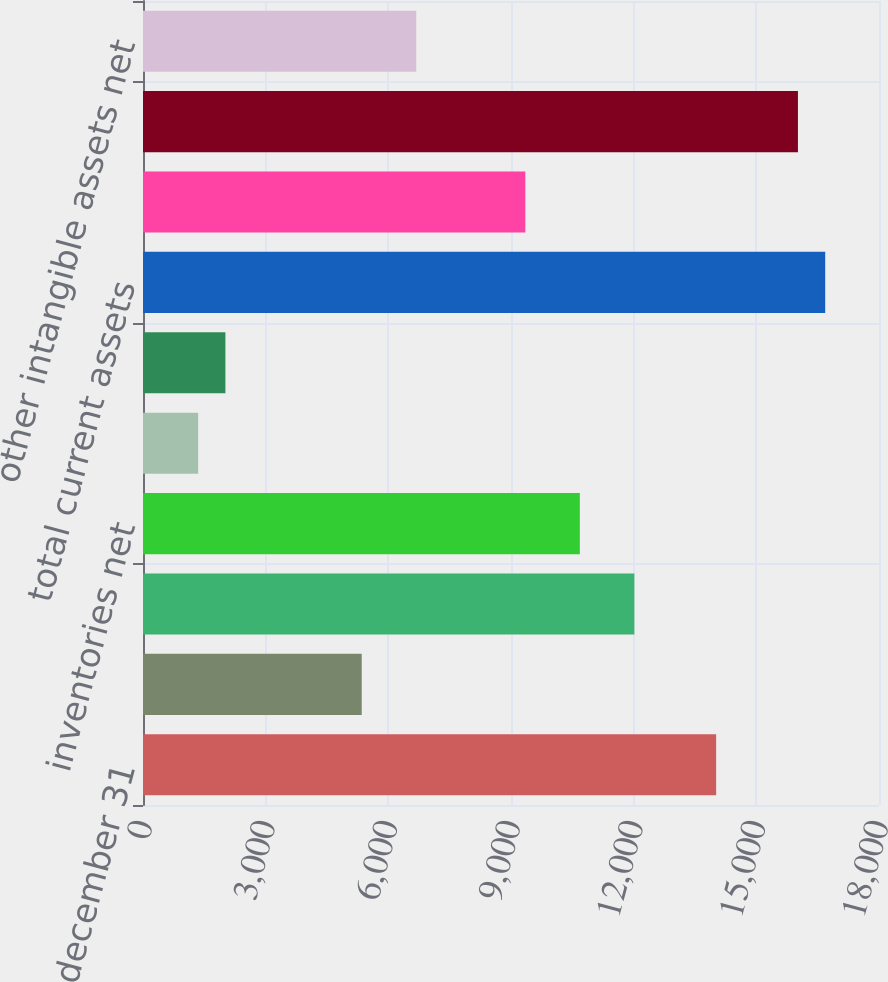Convert chart to OTSL. <chart><loc_0><loc_0><loc_500><loc_500><bar_chart><fcel>december 31<fcel>cash and cash equivalents<fcel>accounts receivable net of<fcel>inventories net<fcel>deferred income taxes<fcel>Prepaid expenses and other<fcel>total current assets<fcel>Property plant and equipment<fcel>Goodwill<fcel>other intangible assets net<nl><fcel>14017.3<fcel>5349.38<fcel>12017<fcel>10683.5<fcel>1348.82<fcel>2015.58<fcel>16684.3<fcel>9349.94<fcel>16017.5<fcel>6682.9<nl></chart> 